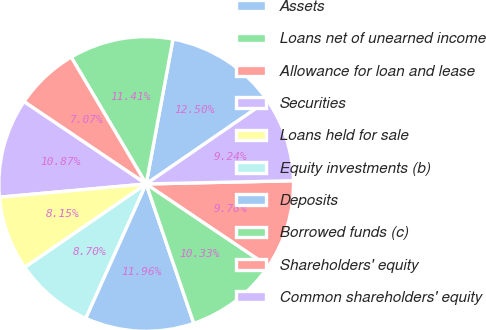Convert chart to OTSL. <chart><loc_0><loc_0><loc_500><loc_500><pie_chart><fcel>Assets<fcel>Loans net of unearned income<fcel>Allowance for loan and lease<fcel>Securities<fcel>Loans held for sale<fcel>Equity investments (b)<fcel>Deposits<fcel>Borrowed funds (c)<fcel>Shareholders' equity<fcel>Common shareholders' equity<nl><fcel>12.5%<fcel>11.41%<fcel>7.07%<fcel>10.87%<fcel>8.15%<fcel>8.7%<fcel>11.96%<fcel>10.33%<fcel>9.78%<fcel>9.24%<nl></chart> 